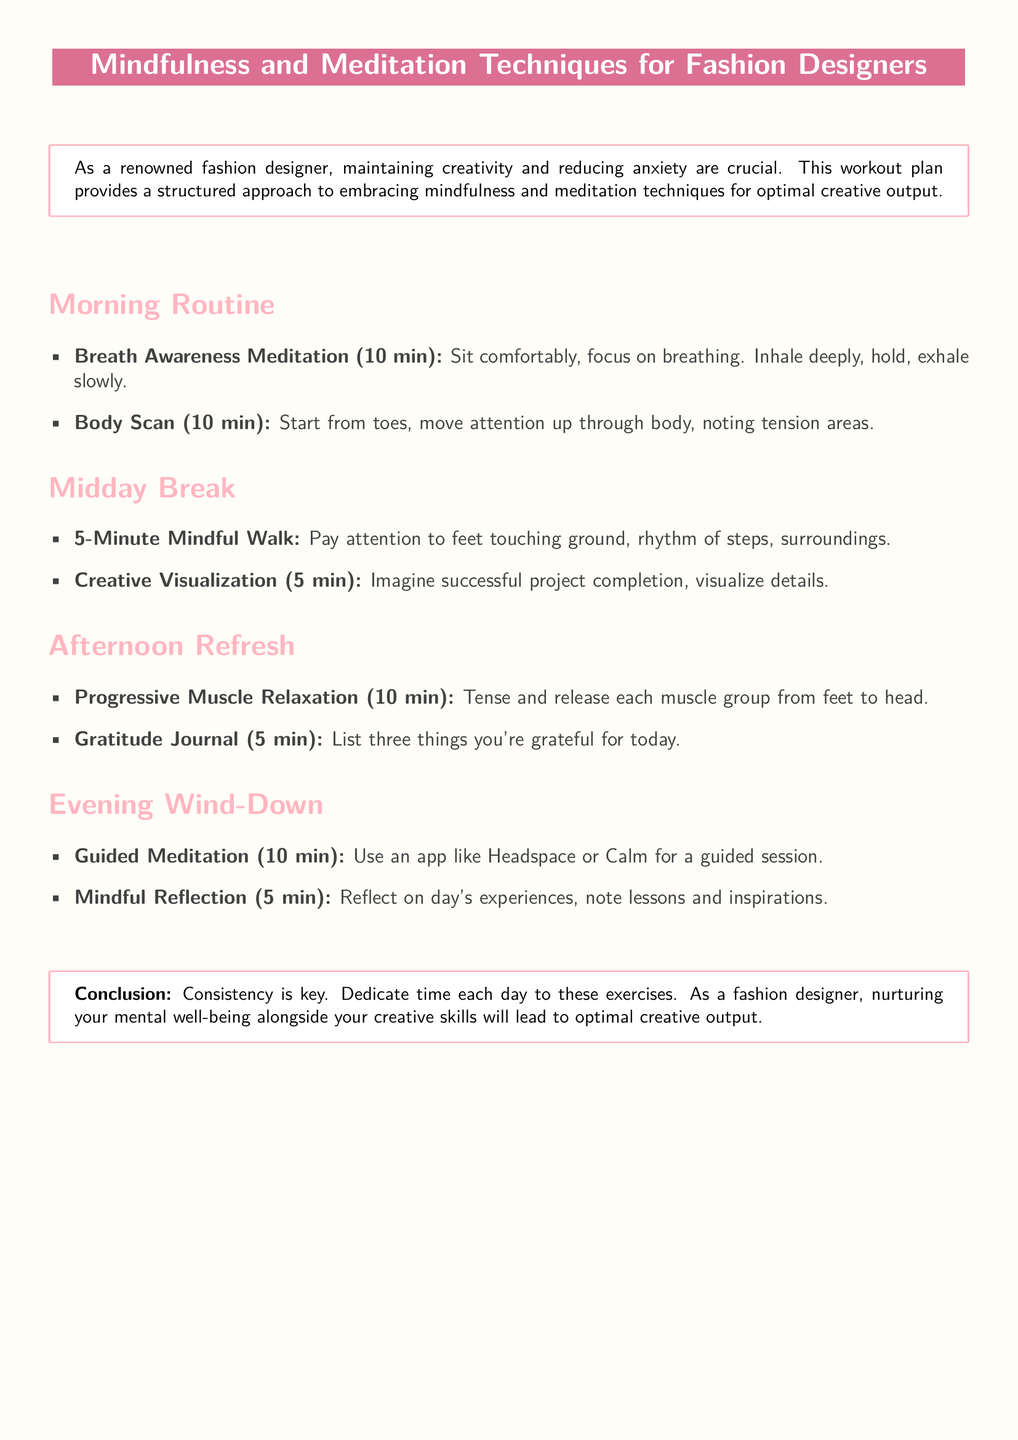what is the primary focus of the workout plan? The document outlines techniques to cultivate focus and reduce anxiety for optimal creative output.
Answer: mindfulness and meditation techniques how long is the Breath Awareness Meditation session? The document specifies a duration of 10 minutes for the Breath Awareness Meditation.
Answer: 10 min what is included in the Midday Break section? The document lists a 5-Minute Mindful Walk and Creative Visualization in the Midday Break section.
Answer: 5-Minute Mindful Walk and Creative Visualization how many minutes are dedicated to Progressive Muscle Relaxation? The document indicates that the Progressive Muscle Relaxation exercise takes 10 minutes.
Answer: 10 min what should be noted in the Gratitude Journal? The document states to list three things you're grateful for today in the Gratitude Journal.
Answer: three things what does the Evening Wind-Down section suggest using for guided meditation? The document recommends using an app like Headspace or Calm for a guided session.
Answer: Headspace or Calm how many key exercises are recommended for the Morning Routine? The document details two exercises in the Morning Routine section.
Answer: two what is emphasized as essential for mental well-being? The conclusion of the document stresses that consistency in dedicating time for exercises is key.
Answer: consistency 